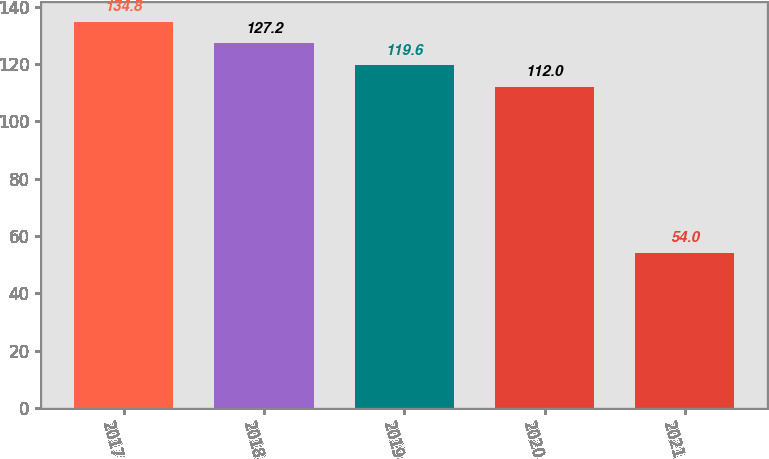<chart> <loc_0><loc_0><loc_500><loc_500><bar_chart><fcel>2017<fcel>2018<fcel>2019<fcel>2020<fcel>2021<nl><fcel>134.8<fcel>127.2<fcel>119.6<fcel>112<fcel>54<nl></chart> 